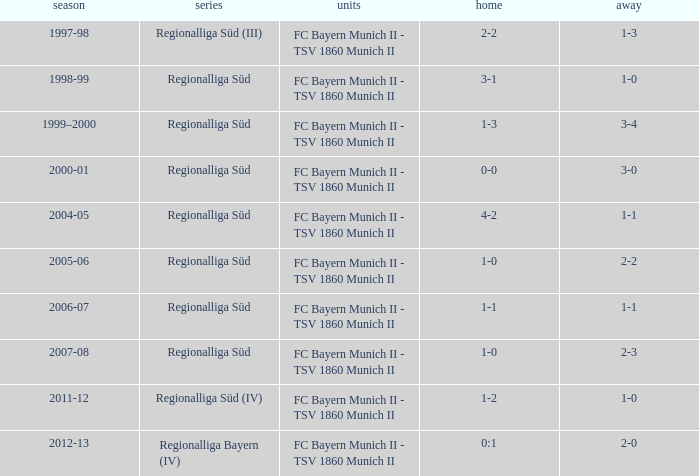What is the home with a 1-1 away in the 2004-05 season? 4-2. 